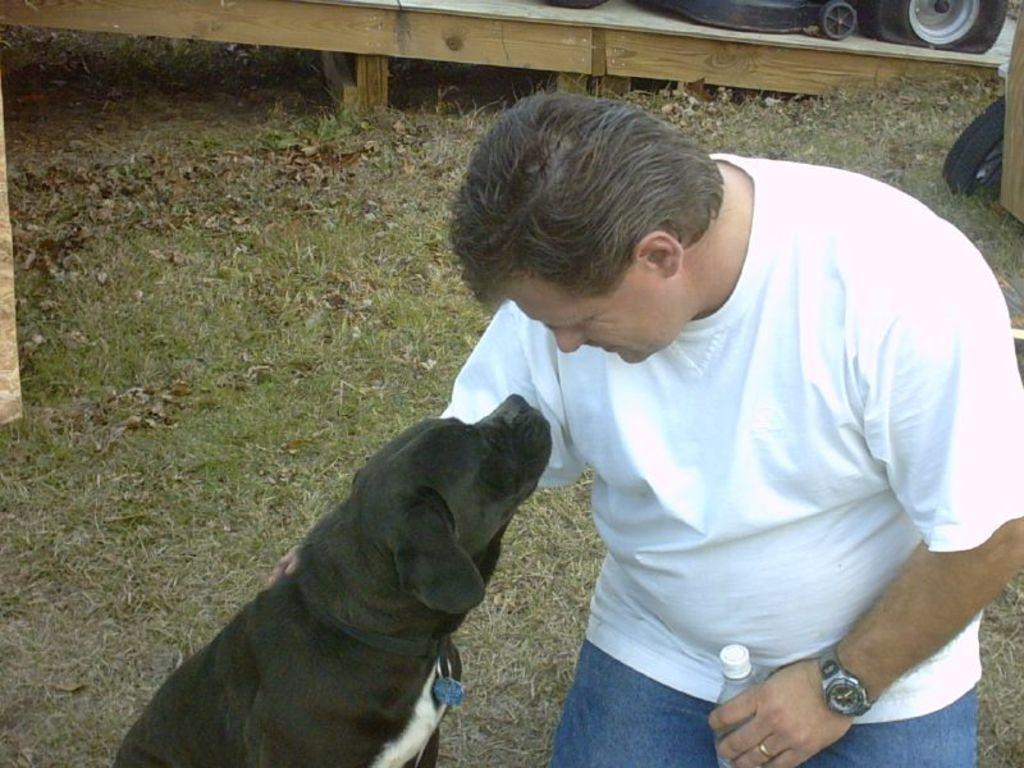What can be seen in the image? There is a person in the image. What is the person wearing? The person is wearing a white shirt. What is the person looking at? The person is looking at a black dog. Where is the black dog located in relation to the person? The black dog is beside the person. What is the person holding in their left hand? The person is holding a water bottle in their left hand. What is the ground covered with? The ground is covered in greenery. What type of hose can be seen in the image? There is no hose present in the image. Is the person wearing a veil in the image? No, the person is not wearing a veil; they are wearing a white shirt. 